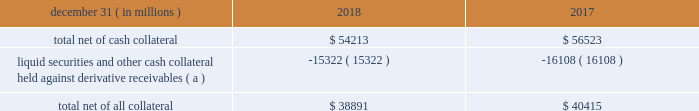Jpmorgan chase & co./2018 form 10-k 117 lending-related commitments the firm uses lending-related financial instruments , such as commitments ( including revolving credit facilities ) and guarantees , to address the financing needs of its clients .
The contractual amounts of these financial instruments represent the maximum possible credit risk should the clients draw down on these commitments or the firm fulfill its obligations under these guarantees , and the clients subsequently fail to perform according to the terms of these contracts .
Most of these commitments and guarantees are refinanced , extended , cancelled , or expire without being drawn upon or a default occurring .
In the firm 2019s view , the total contractual amount of these wholesale lending-related commitments is not representative of the firm 2019s expected future credit exposure or funding requirements .
For further information on wholesale lending-related commitments , refer to note 27 .
Clearing services the firm provides clearing services for clients entering into certain securities and derivative contracts .
Through the provision of these services the firm is exposed to the risk of non-performance by its clients and may be required to share in losses incurred by ccps .
Where possible , the firm seeks to mitigate its credit risk to its clients through the collection of adequate margin at inception and throughout the life of the transactions and can also cease provision of clearing services if clients do not adhere to their obligations under the clearing agreement .
For further discussion of clearing services , refer to note 27 .
Derivative contracts derivatives enable clients and counterparties to manage risks including credit risk and risks arising from fluctuations in interest rates , foreign exchange , equities , and commodities .
The firm makes markets in derivatives in order to meet these needs and uses derivatives to manage certain risks associated with net open risk positions from its market-making activities , including the counterparty credit risk arising from derivative receivables .
The firm also uses derivative instruments to manage its own credit and other market risk exposure .
The nature of the counterparty and the settlement mechanism of the derivative affect the credit risk to which the firm is exposed .
For otc derivatives the firm is exposed to the credit risk of the derivative counterparty .
For exchange-traded derivatives ( 201cetd 201d ) , such as futures and options , and 201ccleared 201d over-the-counter ( 201cotc-cleared 201d ) derivatives , the firm is generally exposed to the credit risk of the relevant ccp .
Where possible , the firm seeks to mitigate its credit risk exposures arising from derivative contracts through the use of legally enforceable master netting arrangements and collateral agreements .
For a further discussion of derivative contracts , counterparties and settlement types , refer to note 5 .
The table summarizes the net derivative receivables for the periods presented .
Derivative receivables .
( a ) includes collateral related to derivative instruments where appropriate legal opinions have not been either sought or obtained with respect to master netting agreements .
The fair value of derivative receivables reported on the consolidated balance sheets were $ 54.2 billion and $ 56.5 billion at december 31 , 2018 and 2017 , respectively .
Derivative receivables represent the fair value of the derivative contracts after giving effect to legally enforceable master netting agreements and cash collateral held by the firm .
However , in management 2019s view , the appropriate measure of current credit risk should also take into consideration additional liquid securities ( primarily u.s .
Government and agency securities and other group of seven nations ( 201cg7 201d ) government securities ) and other cash collateral held by the firm aggregating $ 15.3 billion and $ 16.1 billion at december 31 , 2018 and 2017 , respectively , that may be used as security when the fair value of the client 2019s exposure is in the firm 2019s favor .
In addition to the collateral described in the preceding paragraph , the firm also holds additional collateral ( primarily cash , g7 government securities , other liquid government-agency and guaranteed securities , and corporate debt and equity securities ) delivered by clients at the initiation of transactions , as well as collateral related to contracts that have a non-daily call frequency and collateral that the firm has agreed to return but has not yet settled as of the reporting date .
Although this collateral does not reduce the balances and is not included in the table above , it is available as security against potential exposure that could arise should the fair value of the client 2019s derivative contracts move in the firm 2019s favor .
The derivative receivables fair value , net of all collateral , also does not include other credit enhancements , such as letters of credit .
For additional information on the firm 2019s use of collateral agreements , refer to note 5 .
While useful as a current view of credit exposure , the net fair value of the derivative receivables does not capture the potential future variability of that credit exposure .
To capture the potential future variability of credit exposure , the firm calculates , on a client-by-client basis , three measures of potential derivatives-related credit loss : peak , derivative risk equivalent ( 201cdre 201d ) , and average exposure ( 201cavg 201d ) .
These measures all incorporate netting and collateral benefits , where applicable .
Peak represents a conservative measure of potential exposure to a counterparty calculated in a manner that is broadly equivalent to a 97.5% ( 97.5 % ) confidence level over the life of the transaction .
Peak is the primary measure used by the firm for setting of credit limits for derivative contracts , senior management reporting and derivatives exposure management .
Dre exposure is a measure that expresses the risk of derivative exposure on a basis intended to be .
What is the percentage of the liquid securities and other cash collateral held against derivative receivables in relation with the total net of all collateral in 2018? 
Rationale: its the division between the liquid securities and other cash collateral and total net of all collateral , in 2018 .
Computations: (15322 / 38891)
Answer: 0.39397. 